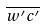<formula> <loc_0><loc_0><loc_500><loc_500>\overline { w ^ { \prime } c ^ { \prime } }</formula> 